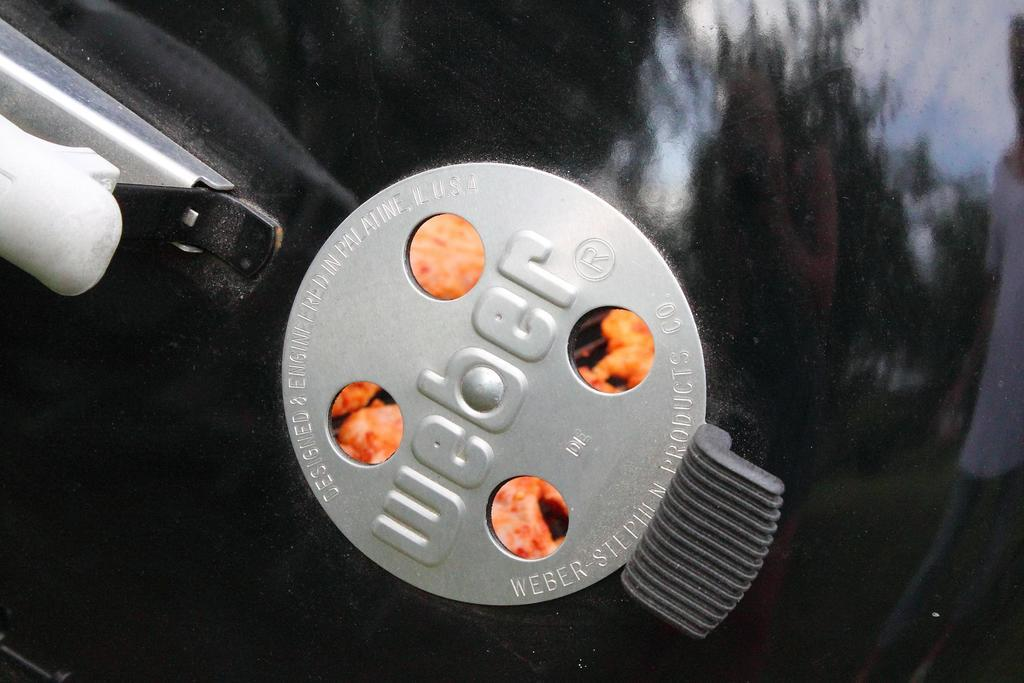What is the color of the object in the image? The object in the image is black-colored. Does the object have any specific features? Yes, the object has a handle and a metal plate on it. What is written on the metal plate? There is text on the metal plate. How many pairs of shoes are visible in the image? There are no shoes present in the image. What type of trade is being conducted in the image? There is no trade being conducted in the image. --- Facts: 1. There is a person holding a book in the image. 2. The person is sitting on a chair. 3. The chair has a cushion. 4. There is a table next to the chair. 5. There is a lamp on the table. Absurd Topics: ocean, dolphin, waves Conversation: What is the person in the image holding? The person in the image is holding a book. Where is the person sitting? The person is sitting on a chair. What is a specific feature of the chair? The chair has a cushion. What is located next to the chair? There is a table next to the chair. What object is on the table? There is a lamp on the table. Reasoning: Let's think step by step in order to produce the conversation. We start by identifying the main subject in the image, which is the person holding a book. Then, we expand the conversation to include other items that are also visible, such as the chair, the cushion, the table, and the lamp. Each question is designed to elicit a specific detail about the image that is known from the provided facts. Absurd Question/Answer: How many dolphins can be seen swimming in the ocean in the image? There are no dolphins or ocean present in the image. What type of waves can be seen crashing against the shore in the image? There are no waves or shore present in the image. 